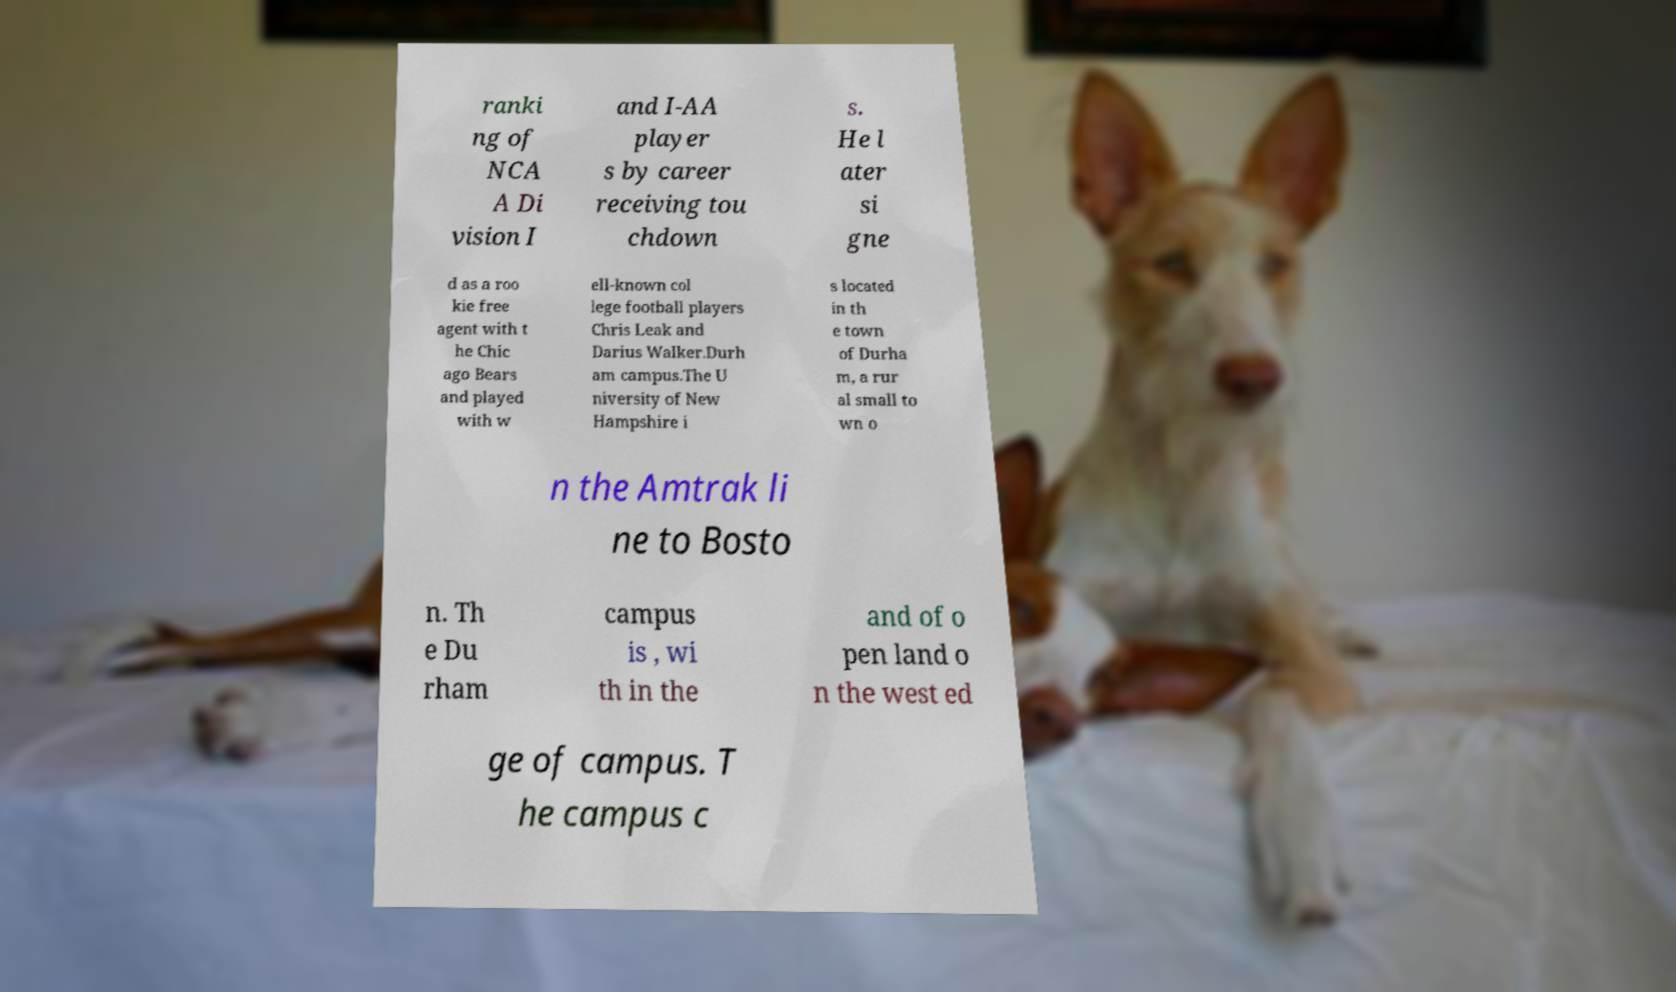Could you extract and type out the text from this image? ranki ng of NCA A Di vision I and I-AA player s by career receiving tou chdown s. He l ater si gne d as a roo kie free agent with t he Chic ago Bears and played with w ell-known col lege football players Chris Leak and Darius Walker.Durh am campus.The U niversity of New Hampshire i s located in th e town of Durha m, a rur al small to wn o n the Amtrak li ne to Bosto n. Th e Du rham campus is , wi th in the and of o pen land o n the west ed ge of campus. T he campus c 